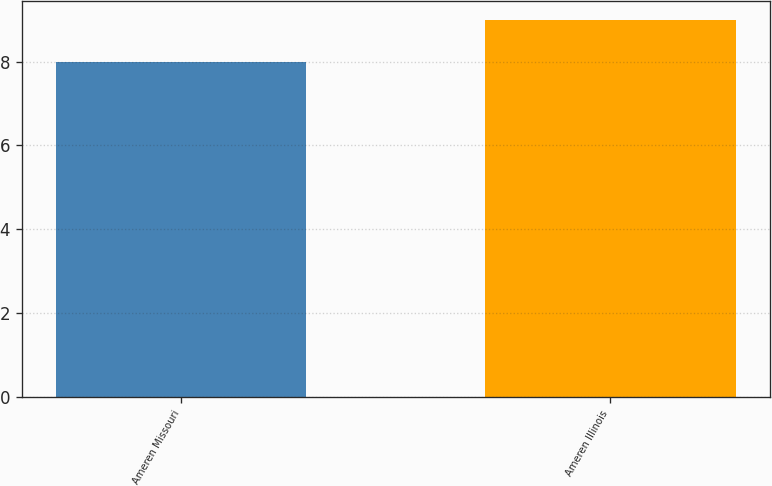<chart> <loc_0><loc_0><loc_500><loc_500><bar_chart><fcel>Ameren Missouri<fcel>Ameren Illinois<nl><fcel>8<fcel>9<nl></chart> 